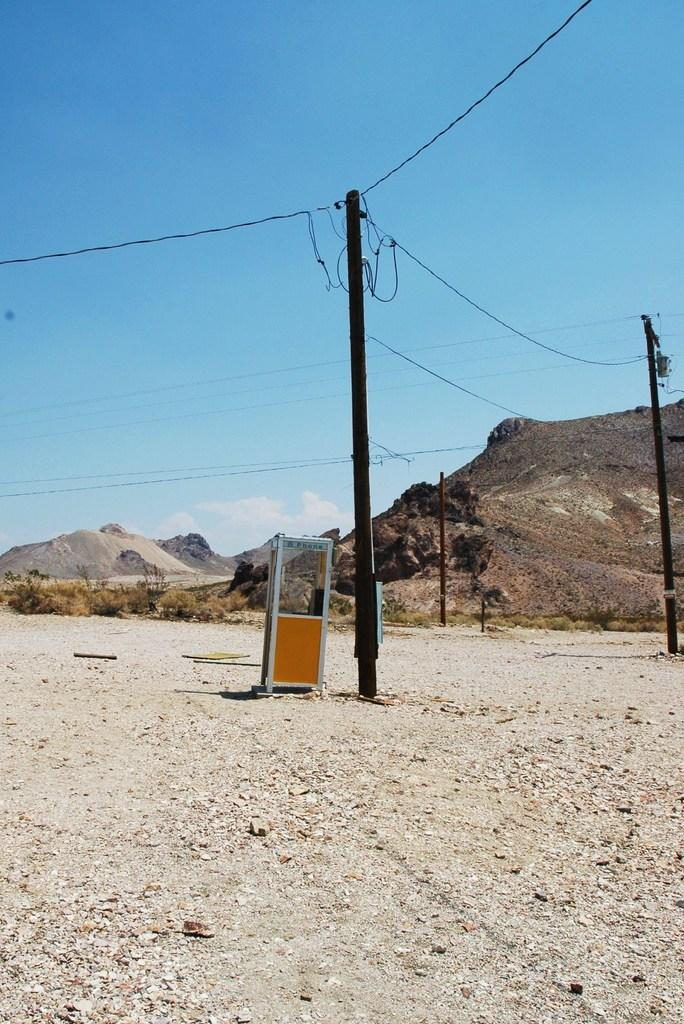What structures can be seen in the image? There are electric poles in the image. What is located in front of the electric poles? There is a booth in front of the electric poles. What type of natural elements are visible in the background of the image? There are rocks in the background of the image. How would you describe the color of the sky in the image? The sky is blue and white in color. What type of ink is being used to write on the pancake in the image? There is no pancake or ink present in the image. Are there any police officers visible in the image? There are no police officers visible in the image. 